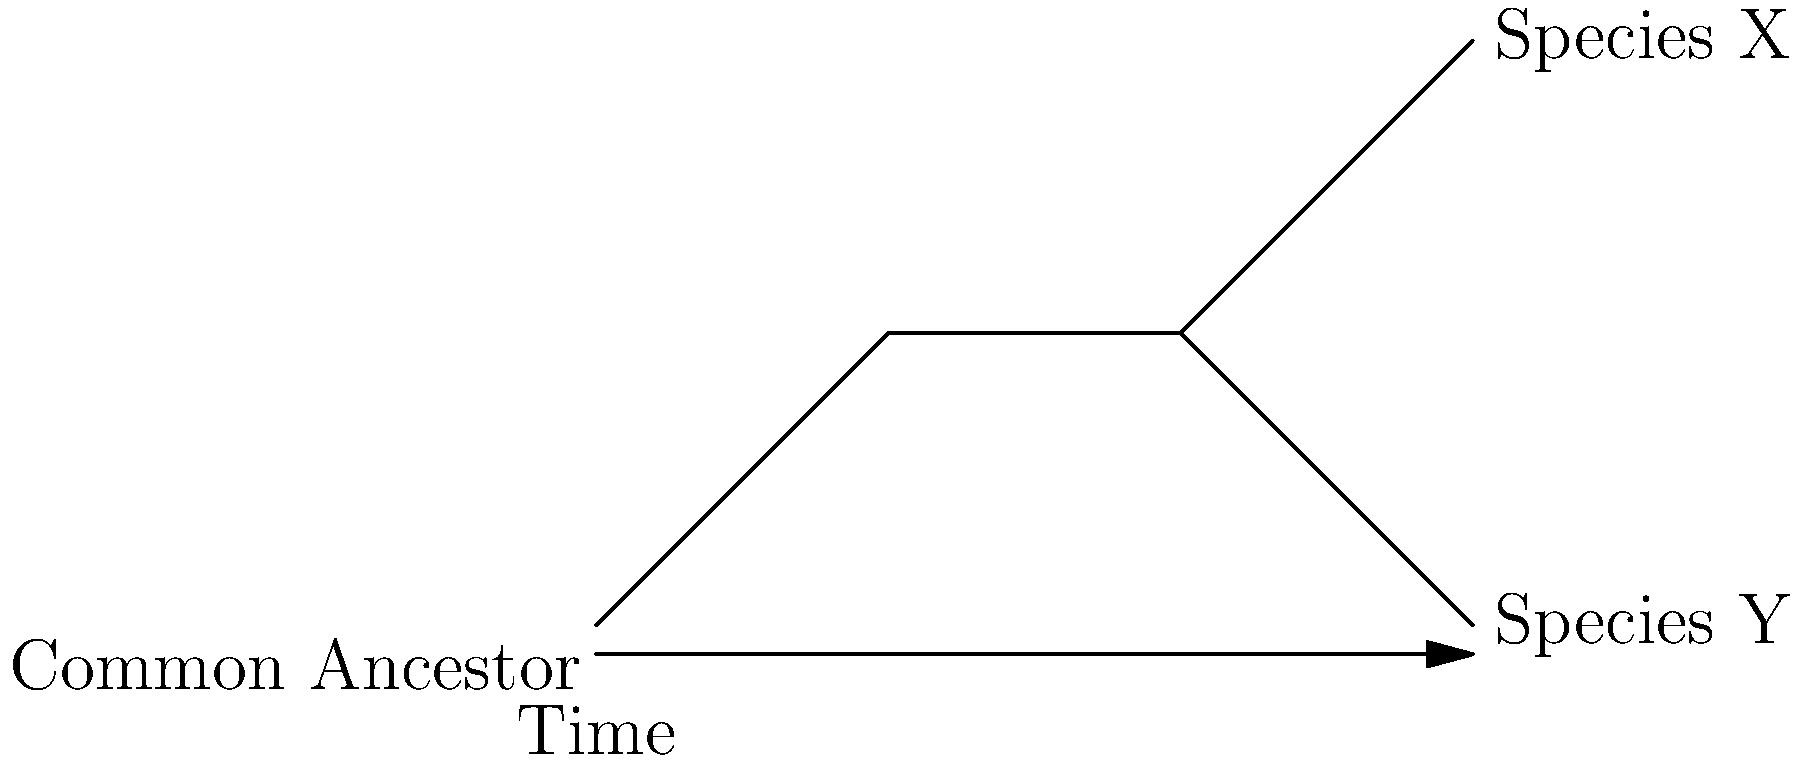As a biotech company employee overseeing funding for genetic research, you're presented with this phylogenetic tree. What can you conclude about the evolutionary relationship between Species X and Species Y? To interpret this phylogenetic tree:

1. Identify the common ancestor: The tree starts from a single point at the left, representing the common ancestor of all species shown.

2. Follow the branches: The tree branches out from left to right, with time progressing in this direction.

3. Analyze branching points: The point where branches split represents a divergence in evolutionary history.

4. Compare branch lengths: In this case, the branches leading to Species X and Species Y are of equal length from their common branching point.

5. Interpret the relationship: Species X and Y share a common ancestor more recent than the root of the tree, but have since diverged into separate species.

6. Consider implications: This suggests that Species X and Y are closely related but distinct species, having evolved separately for the same amount of time since their divergence.

From a biotech perspective, this information could be valuable for:
- Comparing genetic similarities and differences between the species
- Understanding potential shared traits or vulnerabilities
- Developing targeted therapies or interventions based on shared evolutionary history
Answer: Species X and Y are sister taxa, sharing a recent common ancestor but evolving separately since divergence. 